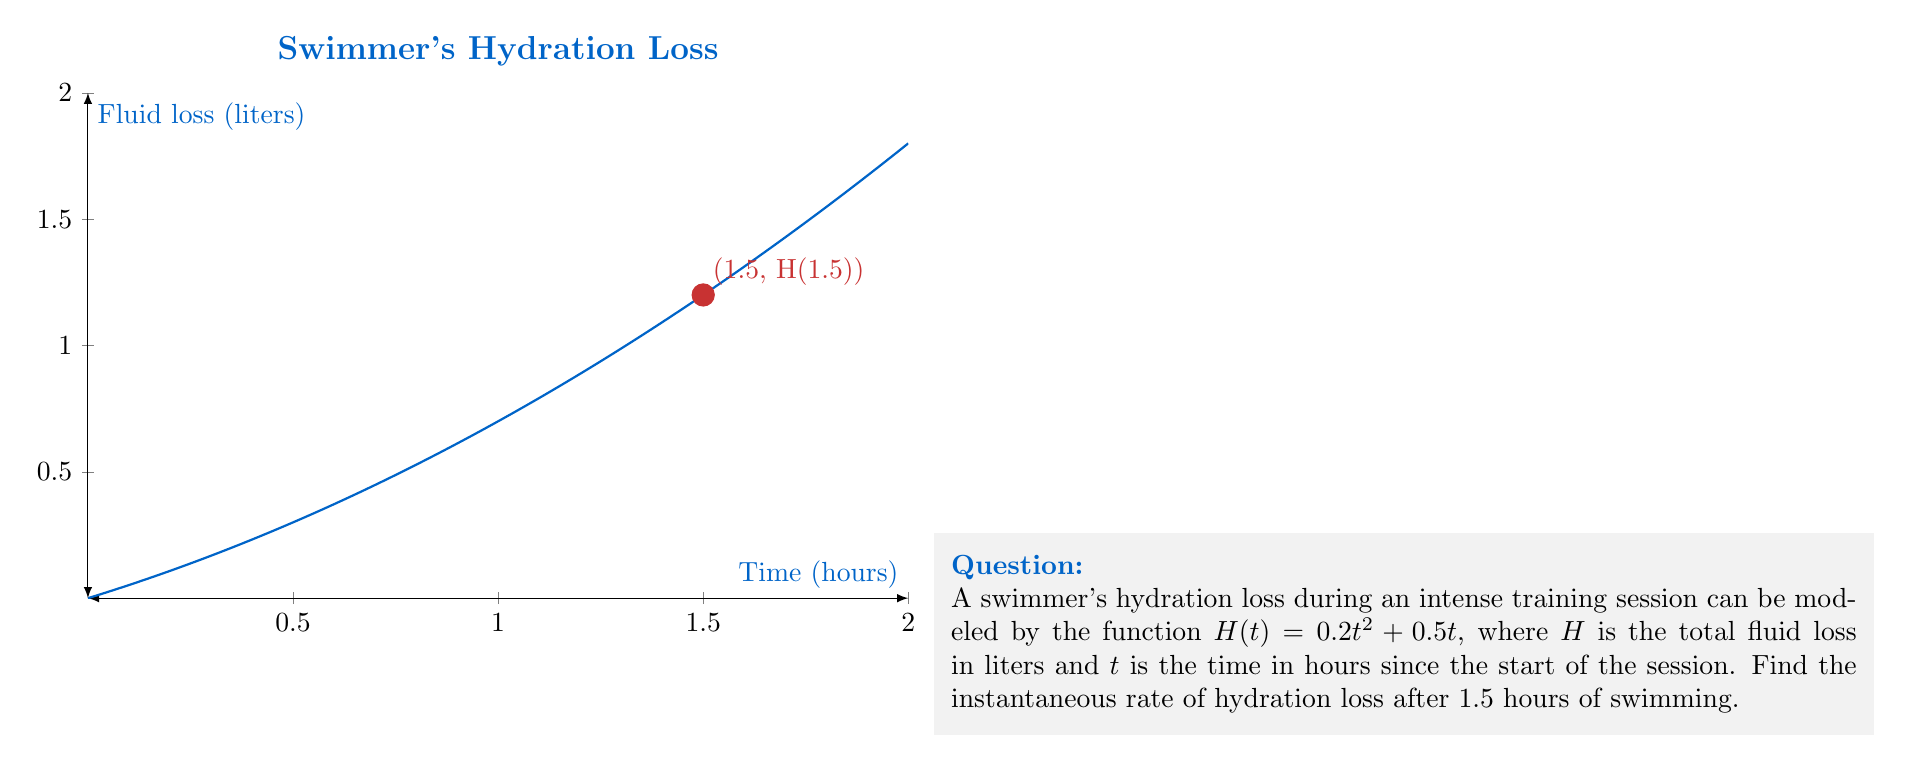Can you answer this question? To find the instantaneous rate of hydration loss, we need to calculate the derivative of the function $H(t)$ and evaluate it at $t = 1.5$ hours.

1) The given function is $H(t) = 0.2t^2 + 0.5t$

2) To find the derivative, we use the power rule and constant multiple rule:
   $$\frac{dH}{dt} = 0.2 \cdot 2t^{2-1} + 0.5$$
   $$\frac{dH}{dt} = 0.4t + 0.5$$

3) This derivative represents the instantaneous rate of hydration loss at any time $t$.

4) To find the rate at 1.5 hours, we substitute $t = 1.5$ into the derivative:
   $$\frac{dH}{dt}\bigg|_{t=1.5} = 0.4(1.5) + 0.5$$
   $$= 0.6 + 0.5 = 1.1$$

5) Therefore, the instantaneous rate of hydration loss after 1.5 hours is 1.1 liters per hour.
Answer: $1.1$ L/h 